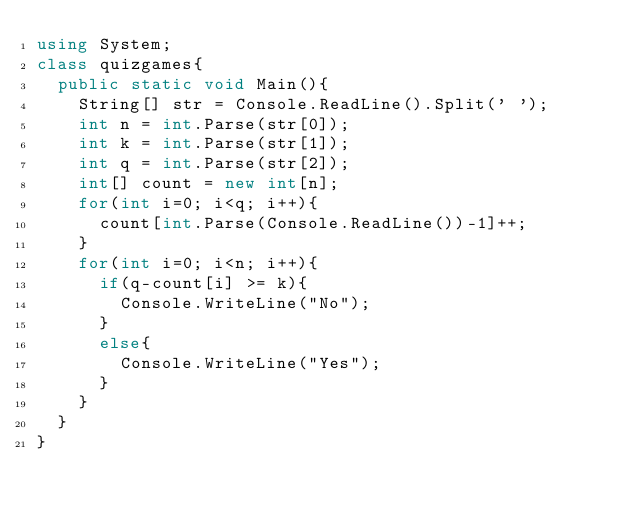<code> <loc_0><loc_0><loc_500><loc_500><_C#_>using System;
class quizgames{
  public static void Main(){
    String[] str = Console.ReadLine().Split(' ');
    int n = int.Parse(str[0]);
    int k = int.Parse(str[1]);
    int q = int.Parse(str[2]);
    int[] count = new int[n];
    for(int i=0; i<q; i++){
      count[int.Parse(Console.ReadLine())-1]++;
    }
    for(int i=0; i<n; i++){
      if(q-count[i] >= k){
        Console.WriteLine("No");
      }
      else{
        Console.WriteLine("Yes");
      }
    }
  }
}
</code> 